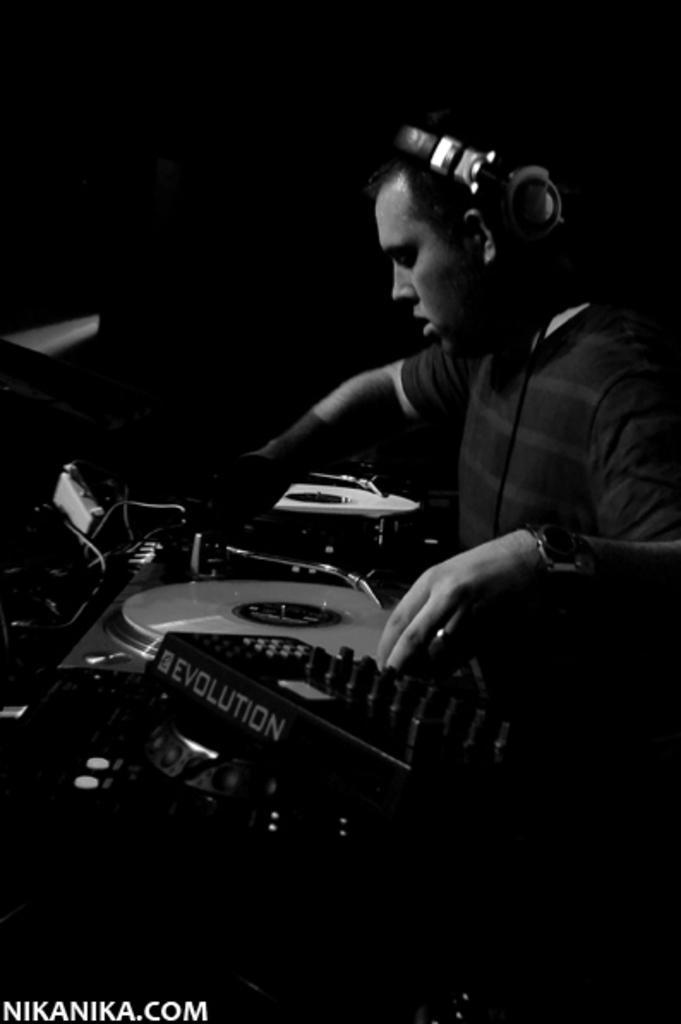Could you give a brief overview of what you see in this image? In this image we can see a black and white image. In this image we can see a person, musical instruments and other objects. In the background of the image there is a dark background. On the image there is a watermark. 